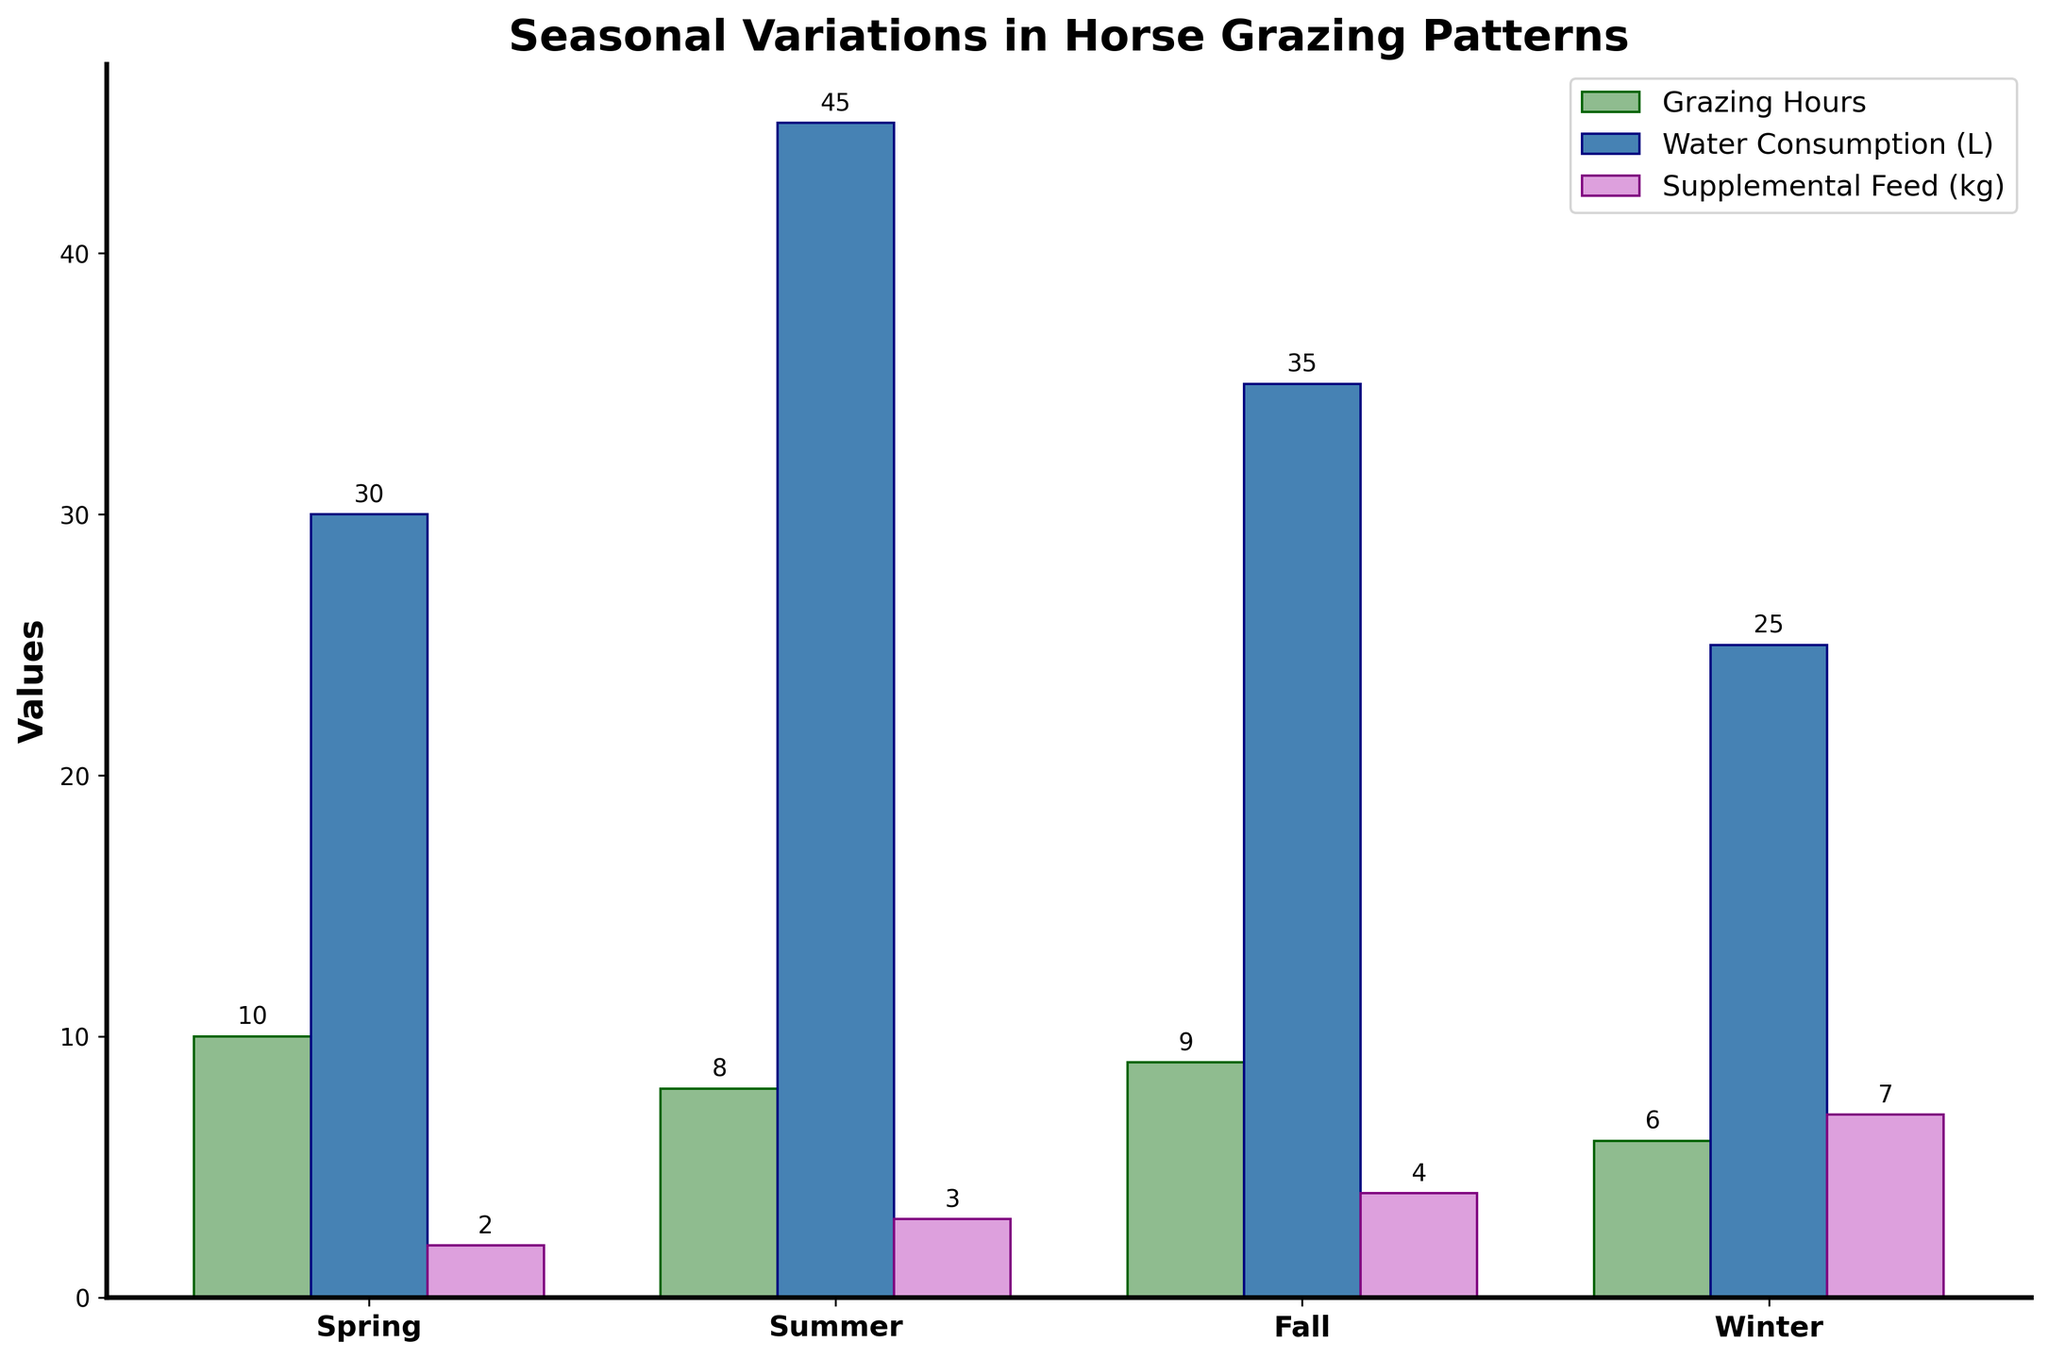Which season has the highest water consumption for horses? Look at the blue bars representing water consumption. The tallest blue bar is during Summer.
Answer: Summer What is the total grazing hours per day for the entire year? Add the grazing hours from each season: 10 (Spring) + 8 (Summer) + 9 (Fall) + 6 (Winter) = 33.
Answer: 33 Which season requires the most supplemental feed? Look at the purple bars representing supplemental feed. The tallest purple bar is during Winter.
Answer: Winter How much more water do horses consume in Summer compared to Winter? Subtract the water consumption in Winter from that in Summer: 45 (Summer) - 25 (Winter) = 20.
Answer: 20 What is the average water consumption per season? Add the water consumption for each season and divide by the number of seasons: (30 + 45 + 35 + 25) / 4 = 33.75.
Answer: 33.75 By how much do grazing hours decrease from Spring to Winter? Subtract Winter grazing hours from Spring grazing hours: 10 - 6 = 4.
Answer: 4 What is the preferred grass type for horses during Fall? Identify the grass type labeled in Fall: Orchard Grass.
Answer: Orchard Grass Compare the grazing hours in Summer and Fall. Which has more, and by how much? Compare the heights of the green bars for Summer and Fall. Fall has 9 hours, and Summer has 8 hours. Difference: 9 - 8 = 1.
Answer: Fall, by 1 hour What is the total amount of supplemental feed required across all seasons? Sum the supplemental feed for each season: 2 + 3 + 4 + 7 = 16.
Answer: 16 Which season has the least horse grazing hours and what is it? Look at the green bars representing grazing hours. The shortest green bar is during Winter, with 6 hours.
Answer: Winter, 6 hours 